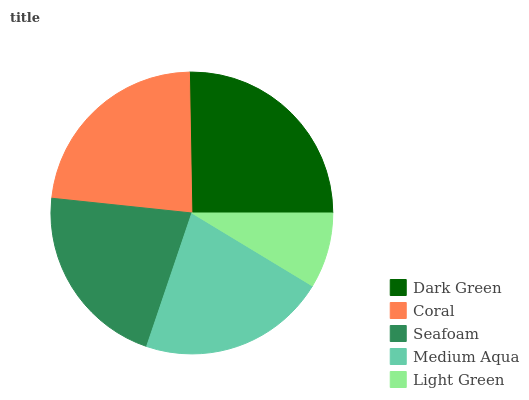Is Light Green the minimum?
Answer yes or no. Yes. Is Dark Green the maximum?
Answer yes or no. Yes. Is Coral the minimum?
Answer yes or no. No. Is Coral the maximum?
Answer yes or no. No. Is Dark Green greater than Coral?
Answer yes or no. Yes. Is Coral less than Dark Green?
Answer yes or no. Yes. Is Coral greater than Dark Green?
Answer yes or no. No. Is Dark Green less than Coral?
Answer yes or no. No. Is Medium Aqua the high median?
Answer yes or no. Yes. Is Medium Aqua the low median?
Answer yes or no. Yes. Is Light Green the high median?
Answer yes or no. No. Is Light Green the low median?
Answer yes or no. No. 